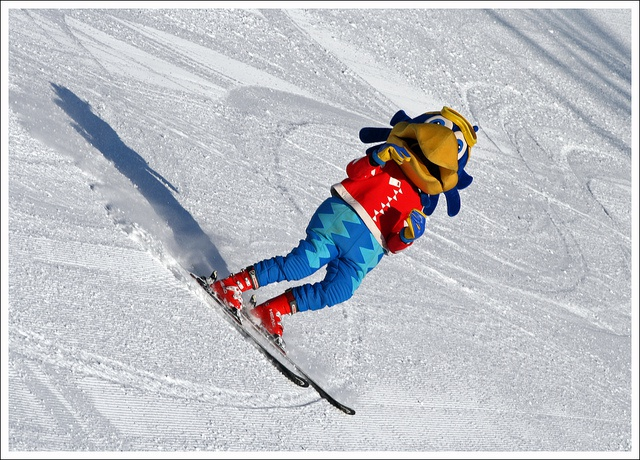Describe the objects in this image and their specific colors. I can see people in black, blue, navy, and red tones and skis in black, darkgray, gray, and lightgray tones in this image. 